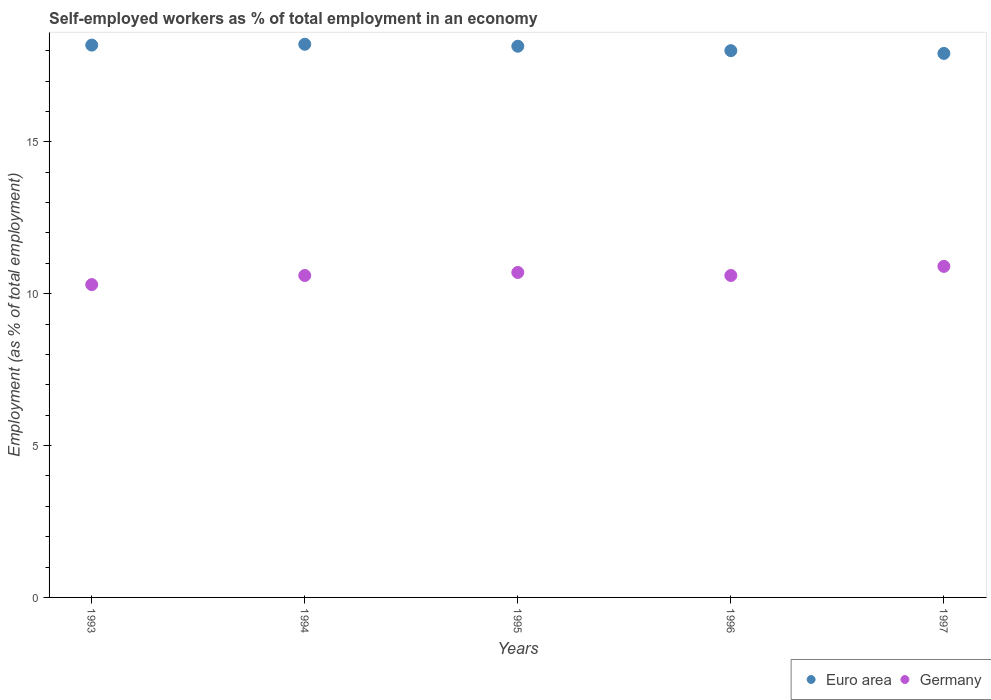How many different coloured dotlines are there?
Ensure brevity in your answer.  2. What is the percentage of self-employed workers in Germany in 1993?
Your answer should be very brief. 10.3. Across all years, what is the maximum percentage of self-employed workers in Germany?
Your response must be concise. 10.9. Across all years, what is the minimum percentage of self-employed workers in Germany?
Make the answer very short. 10.3. In which year was the percentage of self-employed workers in Euro area minimum?
Ensure brevity in your answer.  1997. What is the total percentage of self-employed workers in Germany in the graph?
Offer a terse response. 53.1. What is the difference between the percentage of self-employed workers in Euro area in 1995 and that in 1996?
Provide a succinct answer. 0.15. What is the difference between the percentage of self-employed workers in Germany in 1994 and the percentage of self-employed workers in Euro area in 1996?
Your answer should be compact. -7.4. What is the average percentage of self-employed workers in Germany per year?
Offer a terse response. 10.62. In the year 1995, what is the difference between the percentage of self-employed workers in Germany and percentage of self-employed workers in Euro area?
Provide a short and direct response. -7.45. What is the ratio of the percentage of self-employed workers in Germany in 1993 to that in 1996?
Give a very brief answer. 0.97. Is the difference between the percentage of self-employed workers in Germany in 1993 and 1994 greater than the difference between the percentage of self-employed workers in Euro area in 1993 and 1994?
Provide a short and direct response. No. What is the difference between the highest and the second highest percentage of self-employed workers in Germany?
Keep it short and to the point. 0.2. What is the difference between the highest and the lowest percentage of self-employed workers in Euro area?
Provide a short and direct response. 0.3. Is the sum of the percentage of self-employed workers in Euro area in 1993 and 1995 greater than the maximum percentage of self-employed workers in Germany across all years?
Provide a short and direct response. Yes. Is the percentage of self-employed workers in Germany strictly less than the percentage of self-employed workers in Euro area over the years?
Provide a short and direct response. Yes. What is the difference between two consecutive major ticks on the Y-axis?
Your response must be concise. 5. Are the values on the major ticks of Y-axis written in scientific E-notation?
Provide a succinct answer. No. Does the graph contain any zero values?
Your response must be concise. No. Where does the legend appear in the graph?
Your answer should be very brief. Bottom right. How are the legend labels stacked?
Provide a succinct answer. Horizontal. What is the title of the graph?
Offer a terse response. Self-employed workers as % of total employment in an economy. Does "East Asia (developing only)" appear as one of the legend labels in the graph?
Give a very brief answer. No. What is the label or title of the X-axis?
Make the answer very short. Years. What is the label or title of the Y-axis?
Give a very brief answer. Employment (as % of total employment). What is the Employment (as % of total employment) in Euro area in 1993?
Your answer should be compact. 18.19. What is the Employment (as % of total employment) of Germany in 1993?
Provide a succinct answer. 10.3. What is the Employment (as % of total employment) of Euro area in 1994?
Your answer should be very brief. 18.21. What is the Employment (as % of total employment) of Germany in 1994?
Your answer should be compact. 10.6. What is the Employment (as % of total employment) of Euro area in 1995?
Offer a terse response. 18.15. What is the Employment (as % of total employment) of Germany in 1995?
Your answer should be very brief. 10.7. What is the Employment (as % of total employment) in Euro area in 1996?
Give a very brief answer. 18. What is the Employment (as % of total employment) in Germany in 1996?
Your answer should be compact. 10.6. What is the Employment (as % of total employment) of Euro area in 1997?
Offer a very short reply. 17.91. What is the Employment (as % of total employment) of Germany in 1997?
Offer a terse response. 10.9. Across all years, what is the maximum Employment (as % of total employment) in Euro area?
Your response must be concise. 18.21. Across all years, what is the maximum Employment (as % of total employment) of Germany?
Provide a succinct answer. 10.9. Across all years, what is the minimum Employment (as % of total employment) in Euro area?
Provide a succinct answer. 17.91. Across all years, what is the minimum Employment (as % of total employment) in Germany?
Give a very brief answer. 10.3. What is the total Employment (as % of total employment) in Euro area in the graph?
Give a very brief answer. 90.46. What is the total Employment (as % of total employment) in Germany in the graph?
Your answer should be very brief. 53.1. What is the difference between the Employment (as % of total employment) in Euro area in 1993 and that in 1994?
Your answer should be compact. -0.03. What is the difference between the Employment (as % of total employment) of Euro area in 1993 and that in 1995?
Provide a short and direct response. 0.04. What is the difference between the Employment (as % of total employment) in Euro area in 1993 and that in 1996?
Your answer should be compact. 0.18. What is the difference between the Employment (as % of total employment) in Germany in 1993 and that in 1996?
Offer a terse response. -0.3. What is the difference between the Employment (as % of total employment) in Euro area in 1993 and that in 1997?
Make the answer very short. 0.27. What is the difference between the Employment (as % of total employment) of Germany in 1993 and that in 1997?
Offer a very short reply. -0.6. What is the difference between the Employment (as % of total employment) of Euro area in 1994 and that in 1995?
Provide a succinct answer. 0.06. What is the difference between the Employment (as % of total employment) of Germany in 1994 and that in 1995?
Your response must be concise. -0.1. What is the difference between the Employment (as % of total employment) in Euro area in 1994 and that in 1996?
Make the answer very short. 0.21. What is the difference between the Employment (as % of total employment) of Euro area in 1994 and that in 1997?
Make the answer very short. 0.3. What is the difference between the Employment (as % of total employment) in Germany in 1994 and that in 1997?
Provide a short and direct response. -0.3. What is the difference between the Employment (as % of total employment) of Euro area in 1995 and that in 1996?
Offer a terse response. 0.15. What is the difference between the Employment (as % of total employment) in Germany in 1995 and that in 1996?
Your response must be concise. 0.1. What is the difference between the Employment (as % of total employment) in Euro area in 1995 and that in 1997?
Offer a terse response. 0.24. What is the difference between the Employment (as % of total employment) in Euro area in 1996 and that in 1997?
Ensure brevity in your answer.  0.09. What is the difference between the Employment (as % of total employment) of Euro area in 1993 and the Employment (as % of total employment) of Germany in 1994?
Offer a terse response. 7.59. What is the difference between the Employment (as % of total employment) of Euro area in 1993 and the Employment (as % of total employment) of Germany in 1995?
Your response must be concise. 7.49. What is the difference between the Employment (as % of total employment) in Euro area in 1993 and the Employment (as % of total employment) in Germany in 1996?
Ensure brevity in your answer.  7.59. What is the difference between the Employment (as % of total employment) of Euro area in 1993 and the Employment (as % of total employment) of Germany in 1997?
Ensure brevity in your answer.  7.29. What is the difference between the Employment (as % of total employment) of Euro area in 1994 and the Employment (as % of total employment) of Germany in 1995?
Provide a short and direct response. 7.51. What is the difference between the Employment (as % of total employment) of Euro area in 1994 and the Employment (as % of total employment) of Germany in 1996?
Ensure brevity in your answer.  7.61. What is the difference between the Employment (as % of total employment) in Euro area in 1994 and the Employment (as % of total employment) in Germany in 1997?
Ensure brevity in your answer.  7.31. What is the difference between the Employment (as % of total employment) of Euro area in 1995 and the Employment (as % of total employment) of Germany in 1996?
Offer a very short reply. 7.55. What is the difference between the Employment (as % of total employment) of Euro area in 1995 and the Employment (as % of total employment) of Germany in 1997?
Your answer should be very brief. 7.25. What is the difference between the Employment (as % of total employment) in Euro area in 1996 and the Employment (as % of total employment) in Germany in 1997?
Ensure brevity in your answer.  7.1. What is the average Employment (as % of total employment) of Euro area per year?
Provide a short and direct response. 18.09. What is the average Employment (as % of total employment) in Germany per year?
Offer a very short reply. 10.62. In the year 1993, what is the difference between the Employment (as % of total employment) in Euro area and Employment (as % of total employment) in Germany?
Make the answer very short. 7.89. In the year 1994, what is the difference between the Employment (as % of total employment) in Euro area and Employment (as % of total employment) in Germany?
Give a very brief answer. 7.61. In the year 1995, what is the difference between the Employment (as % of total employment) of Euro area and Employment (as % of total employment) of Germany?
Your response must be concise. 7.45. In the year 1996, what is the difference between the Employment (as % of total employment) of Euro area and Employment (as % of total employment) of Germany?
Your answer should be compact. 7.4. In the year 1997, what is the difference between the Employment (as % of total employment) in Euro area and Employment (as % of total employment) in Germany?
Make the answer very short. 7.01. What is the ratio of the Employment (as % of total employment) in Euro area in 1993 to that in 1994?
Make the answer very short. 1. What is the ratio of the Employment (as % of total employment) in Germany in 1993 to that in 1994?
Your response must be concise. 0.97. What is the ratio of the Employment (as % of total employment) of Germany in 1993 to that in 1995?
Give a very brief answer. 0.96. What is the ratio of the Employment (as % of total employment) of Euro area in 1993 to that in 1996?
Your answer should be compact. 1.01. What is the ratio of the Employment (as % of total employment) in Germany in 1993 to that in 1996?
Provide a short and direct response. 0.97. What is the ratio of the Employment (as % of total employment) of Euro area in 1993 to that in 1997?
Make the answer very short. 1.02. What is the ratio of the Employment (as % of total employment) of Germany in 1993 to that in 1997?
Keep it short and to the point. 0.94. What is the ratio of the Employment (as % of total employment) of Germany in 1994 to that in 1995?
Your response must be concise. 0.99. What is the ratio of the Employment (as % of total employment) of Euro area in 1994 to that in 1996?
Give a very brief answer. 1.01. What is the ratio of the Employment (as % of total employment) in Germany in 1994 to that in 1996?
Ensure brevity in your answer.  1. What is the ratio of the Employment (as % of total employment) in Euro area in 1994 to that in 1997?
Offer a terse response. 1.02. What is the ratio of the Employment (as % of total employment) of Germany in 1994 to that in 1997?
Provide a short and direct response. 0.97. What is the ratio of the Employment (as % of total employment) in Euro area in 1995 to that in 1996?
Give a very brief answer. 1.01. What is the ratio of the Employment (as % of total employment) in Germany in 1995 to that in 1996?
Provide a succinct answer. 1.01. What is the ratio of the Employment (as % of total employment) in Euro area in 1995 to that in 1997?
Your answer should be compact. 1.01. What is the ratio of the Employment (as % of total employment) in Germany in 1995 to that in 1997?
Keep it short and to the point. 0.98. What is the ratio of the Employment (as % of total employment) of Euro area in 1996 to that in 1997?
Give a very brief answer. 1.01. What is the ratio of the Employment (as % of total employment) in Germany in 1996 to that in 1997?
Your answer should be compact. 0.97. What is the difference between the highest and the second highest Employment (as % of total employment) of Euro area?
Provide a succinct answer. 0.03. What is the difference between the highest and the second highest Employment (as % of total employment) of Germany?
Make the answer very short. 0.2. What is the difference between the highest and the lowest Employment (as % of total employment) in Euro area?
Keep it short and to the point. 0.3. What is the difference between the highest and the lowest Employment (as % of total employment) of Germany?
Keep it short and to the point. 0.6. 